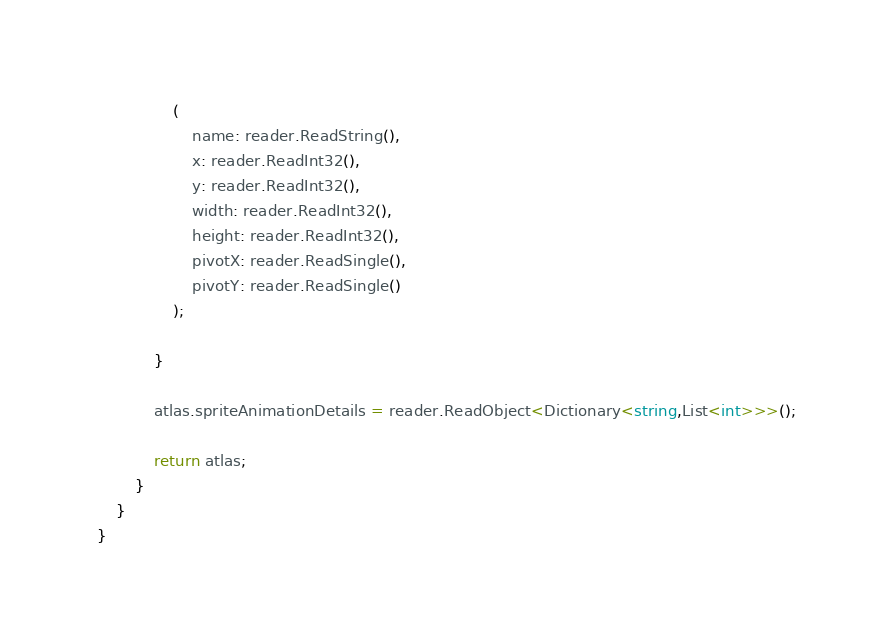<code> <loc_0><loc_0><loc_500><loc_500><_C#_>				(
					name: reader.ReadString(),
					x: reader.ReadInt32(),
					y: reader.ReadInt32(),
					width: reader.ReadInt32(),
					height: reader.ReadInt32(),
					pivotX: reader.ReadSingle(),
					pivotY: reader.ReadSingle()
				);

			}

			atlas.spriteAnimationDetails = reader.ReadObject<Dictionary<string,List<int>>>();

			return atlas;
		}
	}
}</code> 